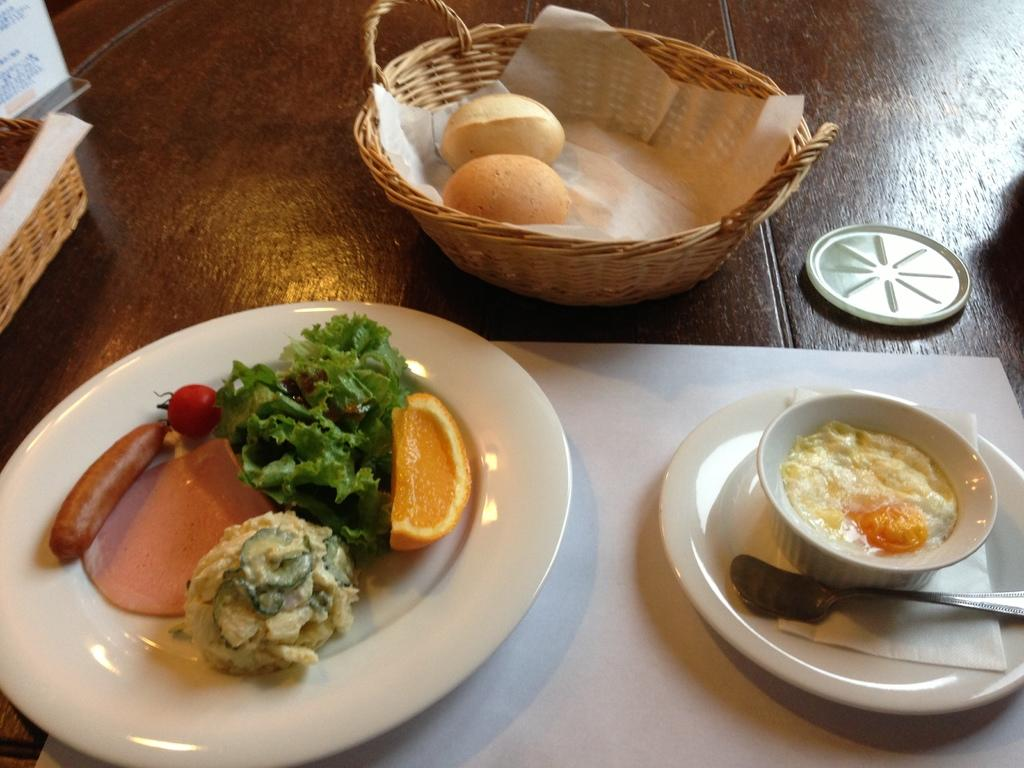What is the primary object on which the food items are placed in the image? There are food items on a plate, in a bowl, and in a basket in the image. What is the purpose of the lid in the image? The purpose of the lid is not clear from the image, but it might be used to cover or protect the food items. What type of surface is the food placed on in the image? The food items are placed on a wooden table in the image. Can you describe any other items visible on the wooden table? There are no other items mentioned in the provided facts, so we cannot describe any additional items on the wooden table. How does the fog affect the food items in the image? There is no fog present in the image, so it cannot affect the food items. 